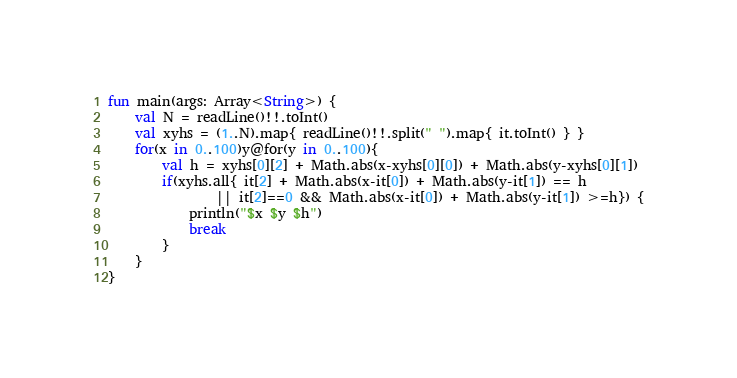Convert code to text. <code><loc_0><loc_0><loc_500><loc_500><_Kotlin_>fun main(args: Array<String>) {
    val N = readLine()!!.toInt()
    val xyhs = (1..N).map{ readLine()!!.split(" ").map{ it.toInt() } }
    for(x in 0..100)y@for(y in 0..100){
        val h = xyhs[0][2] + Math.abs(x-xyhs[0][0]) + Math.abs(y-xyhs[0][1])
        if(xyhs.all{ it[2] + Math.abs(x-it[0]) + Math.abs(y-it[1]) == h
                || it[2]==0 && Math.abs(x-it[0]) + Math.abs(y-it[1]) >=h}) {
            println("$x $y $h")
            break
        }
    }
}</code> 